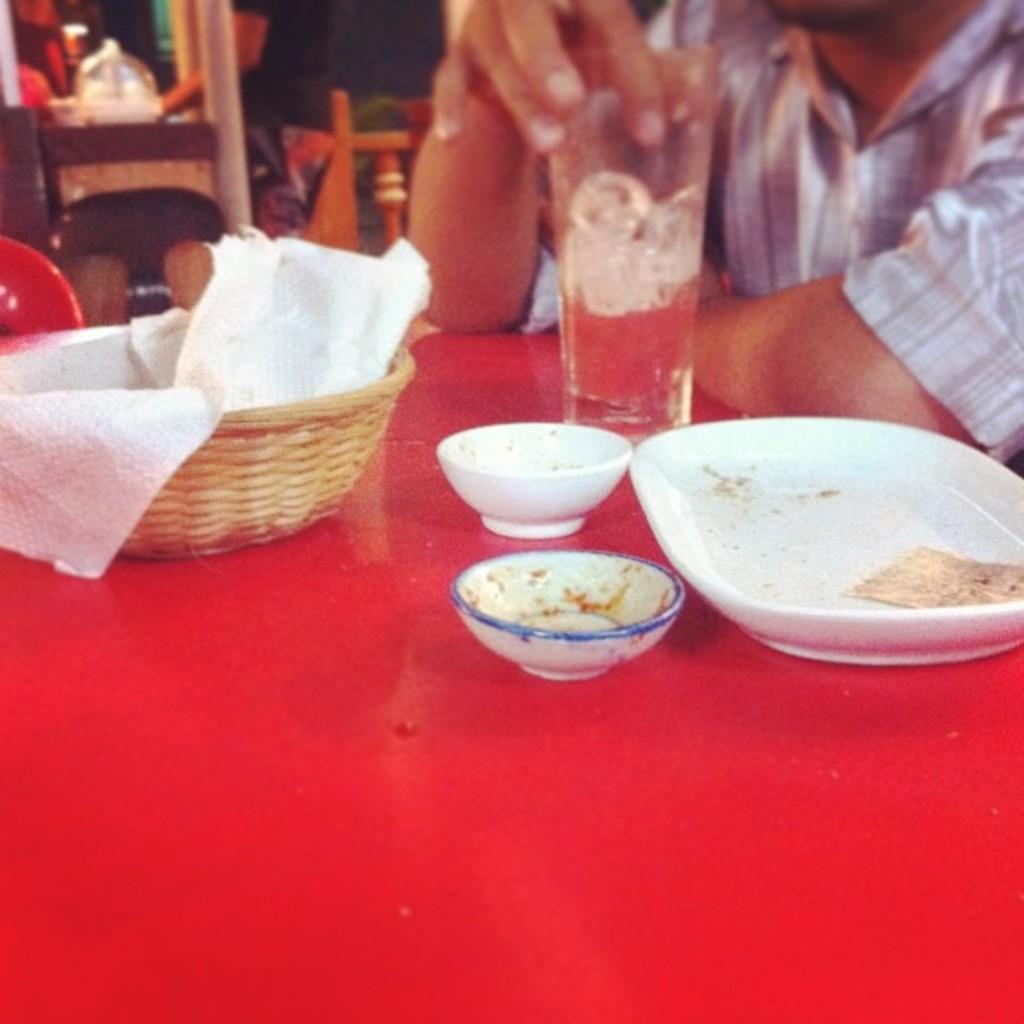How would you summarize this image in a sentence or two? In this image we can see one red color table. On table we can see basket, tissues, bowls and plate. Background of the image, one person is there who is wearing shirt and wooden thing is present. 